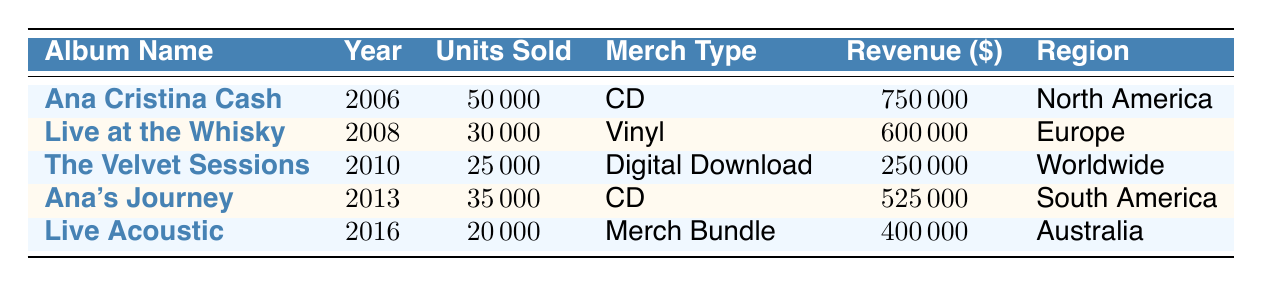What is the total revenue generated from the album "Ana Cristina Cash"? The table shows that for the album "Ana Cristina Cash," the sales revenue is listed as 750000. Therefore, the total revenue generated from this album is 750000.
Answer: 750000 Which region had the highest units sold? By inspecting the "units sold" column, we see that "Ana Cristina Cash" had the highest units sold at 50000 in North America.
Answer: North America What type of merchandise had the lowest revenue? The merchandise type with the lowest revenue is "Digital Download" from "The Velvet Sessions," which has a revenue of 250000.
Answer: Digital Download Is the total units sold for albums released before 2010 greater than 80000? The units sold for albums before 2010 are 50000 (Ana Cristina Cash) + 30000 (Live at the Whisky) + 25000 (The Velvet Sessions) = 105000, which is greater than 80000.
Answer: Yes What is the average revenue for all albums sold? To compute the average revenue, we first sum the revenues: 750000 + 600000 + 250000 + 525000 + 400000 = 2525000. There are 5 albums, so the average revenue is 2525000 / 5 = 505000.
Answer: 505000 How many units were sold in South America? The table shows that "Ana's Journey," sold in South America, had 35000 units sold.
Answer: 35000 Is it true that all albums sold merchandise bundles? A quick look indicates that only "Live Acoustic" is listed as a merch bundle. Therefore, it is false that all albums sold merchandise bundles.
Answer: No Which album, released in 2013, had a specific type of merchandise? The album released in 2013 is "Ana's Journey," which had the merchandise type listed as "CD."
Answer: CD What is the difference in revenue between the highest and lowest selling albums? The highest selling album by revenue is "Ana Cristina Cash" at 750000 and the lowest is "The Velvet Sessions" at 250000. The difference is 750000 - 250000 = 500000.
Answer: 500000 